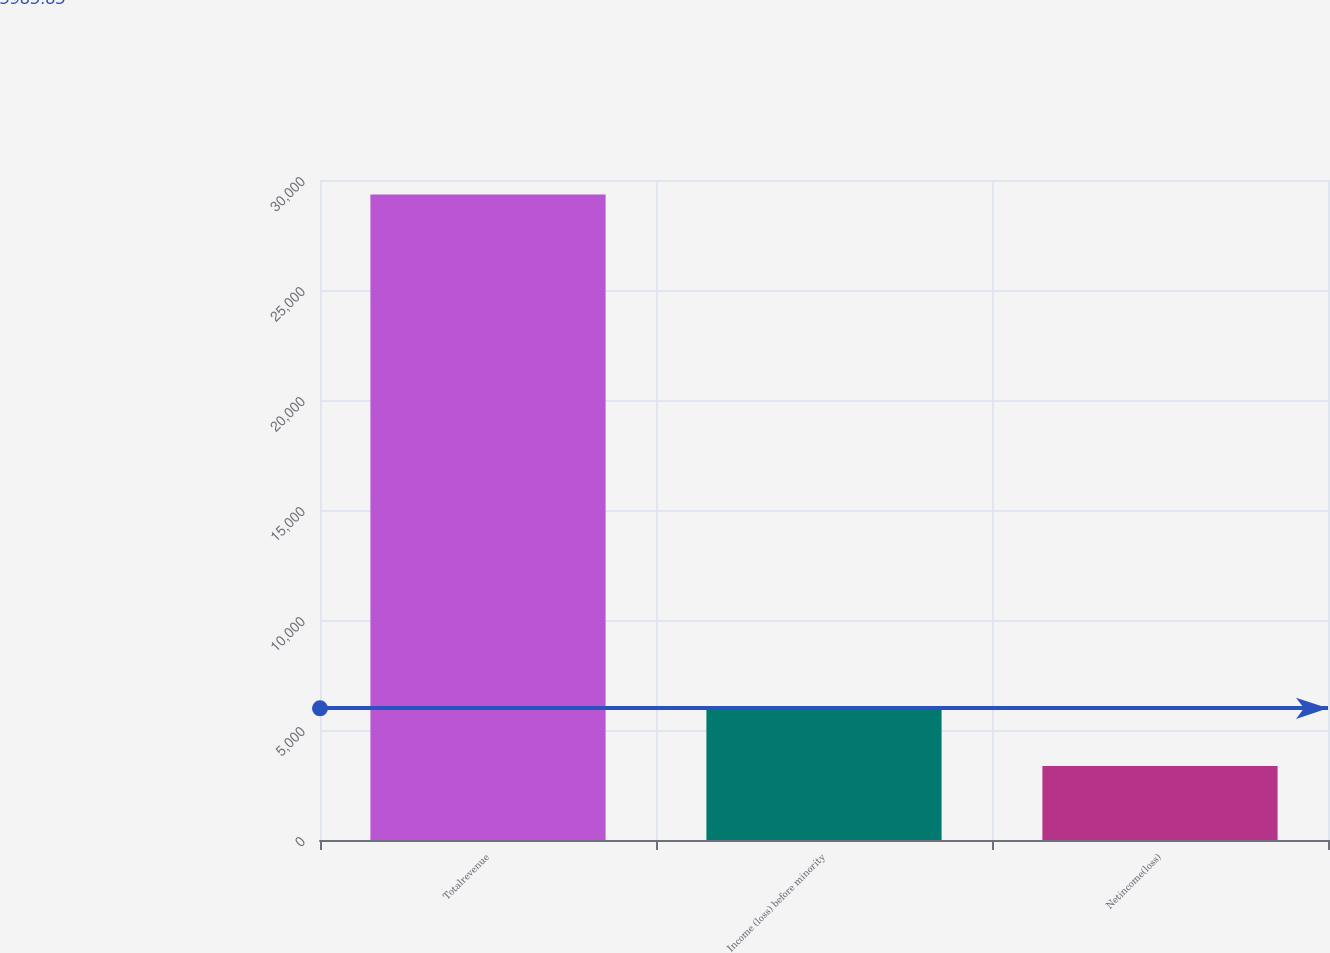Convert chart. <chart><loc_0><loc_0><loc_500><loc_500><bar_chart><fcel>Totalrevenue<fcel>Income (loss) before minority<fcel>Netincome(loss)<nl><fcel>29346<fcel>5957.7<fcel>3359<nl></chart> 